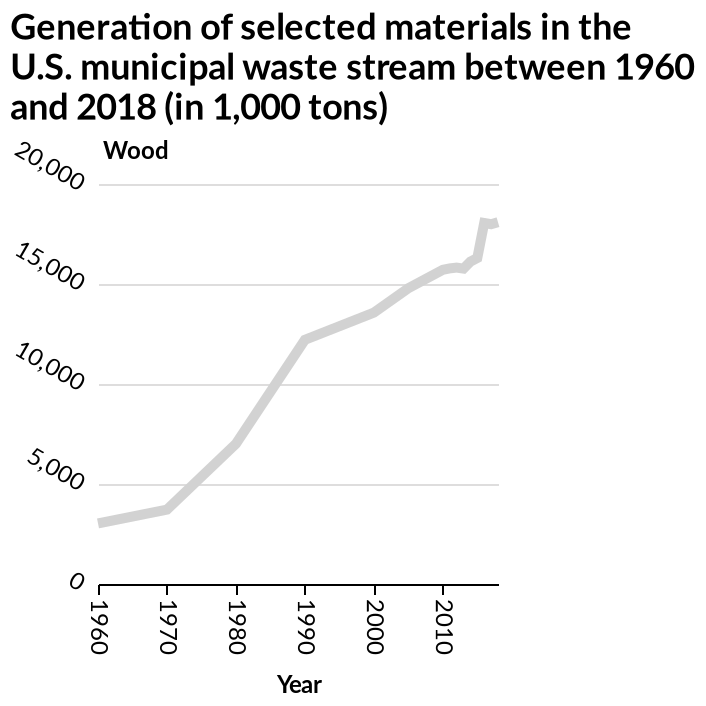<image>
please summary the statistics and relations of the chart You can see that as the years increase, so does the amount of wood found in the U.S. municipal waste stream. 1960 has the lowest amount, which is under 5000 tons. What material is marked on the y-axis? Wood is marked on the y-axis. Describe the following image in detail This line chart is labeled Generation of selected materials in the U.S. municipal waste stream between 1960 and 2018 (in 1,000 tons). A linear scale of range 0 to 20,000 can be found along the y-axis, marked Wood. Along the x-axis, Year is shown as a linear scale of range 1960 to 2010. Does the amount of wood in the U.S. municipal waste stream decrease over time?  No, it increases as the years increase. 